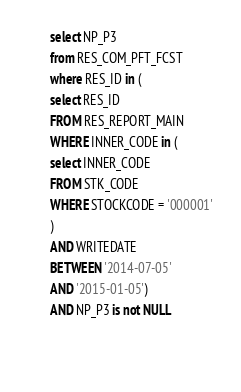Convert code to text. <code><loc_0><loc_0><loc_500><loc_500><_SQL_>
       select NP_P3
       from RES_COM_PFT_FCST
       where RES_ID in (
       select RES_ID
       FROM RES_REPORT_MAIN
       WHERE INNER_CODE in (
       select INNER_CODE
       FROM STK_CODE
       WHERE STOCKCODE = '000001'
       )
       AND WRITEDATE
       BETWEEN '2014-07-05'
       AND '2015-01-05')
       AND NP_P3 is not NULL
       
			</code> 